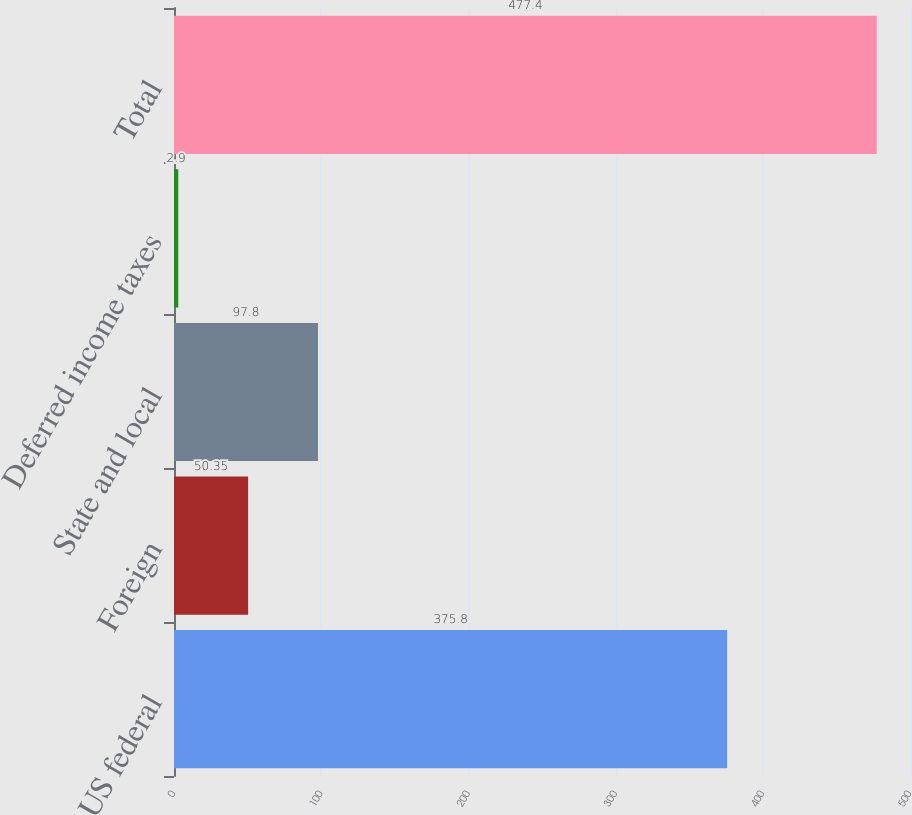Convert chart. <chart><loc_0><loc_0><loc_500><loc_500><bar_chart><fcel>US federal<fcel>Foreign<fcel>State and local<fcel>Deferred income taxes<fcel>Total<nl><fcel>375.8<fcel>50.35<fcel>97.8<fcel>2.9<fcel>477.4<nl></chart> 